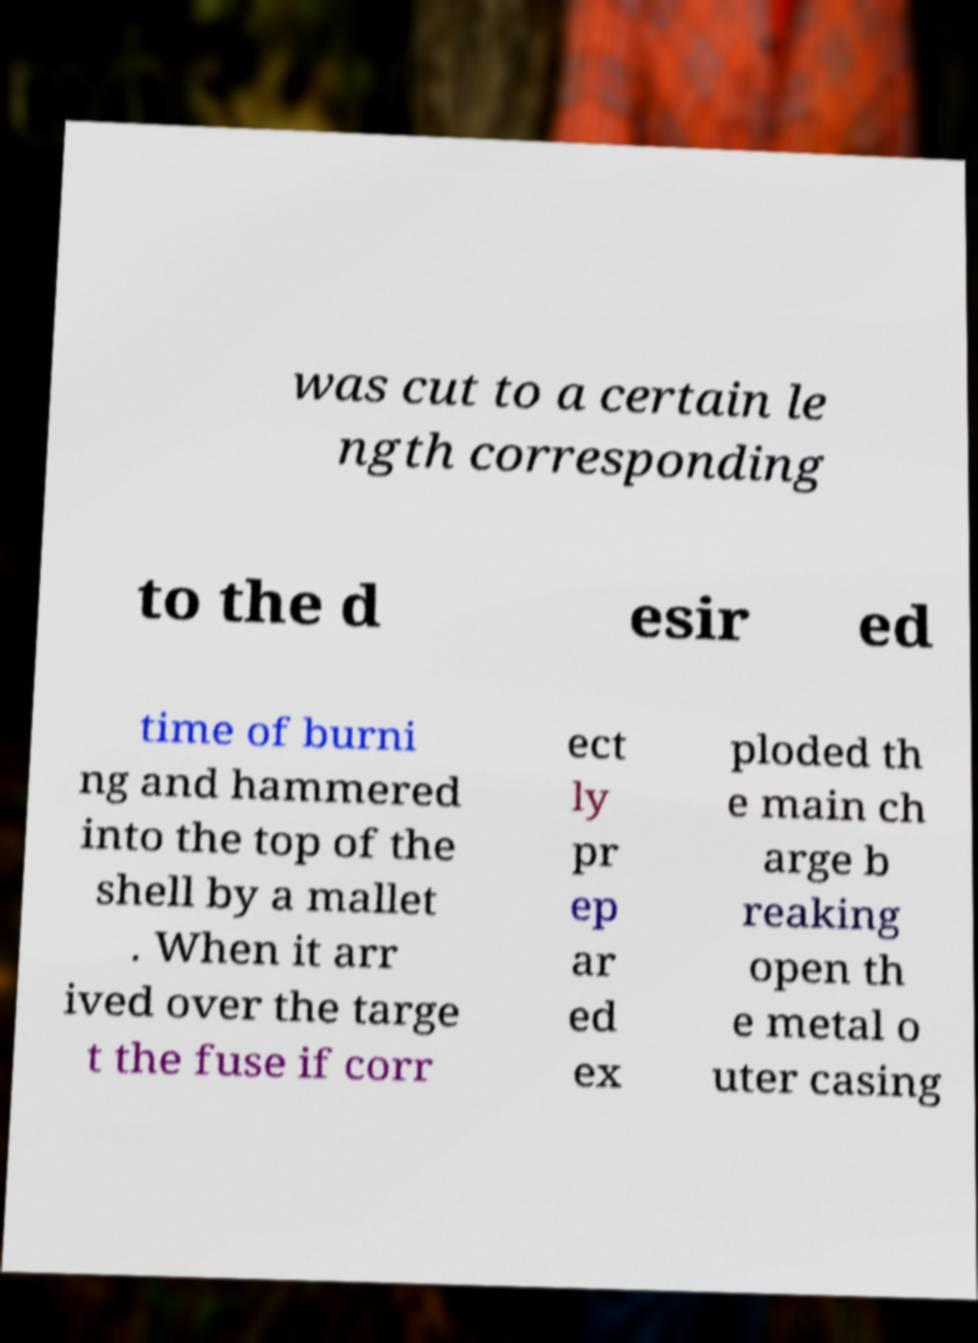Can you read and provide the text displayed in the image?This photo seems to have some interesting text. Can you extract and type it out for me? was cut to a certain le ngth corresponding to the d esir ed time of burni ng and hammered into the top of the shell by a mallet . When it arr ived over the targe t the fuse if corr ect ly pr ep ar ed ex ploded th e main ch arge b reaking open th e metal o uter casing 